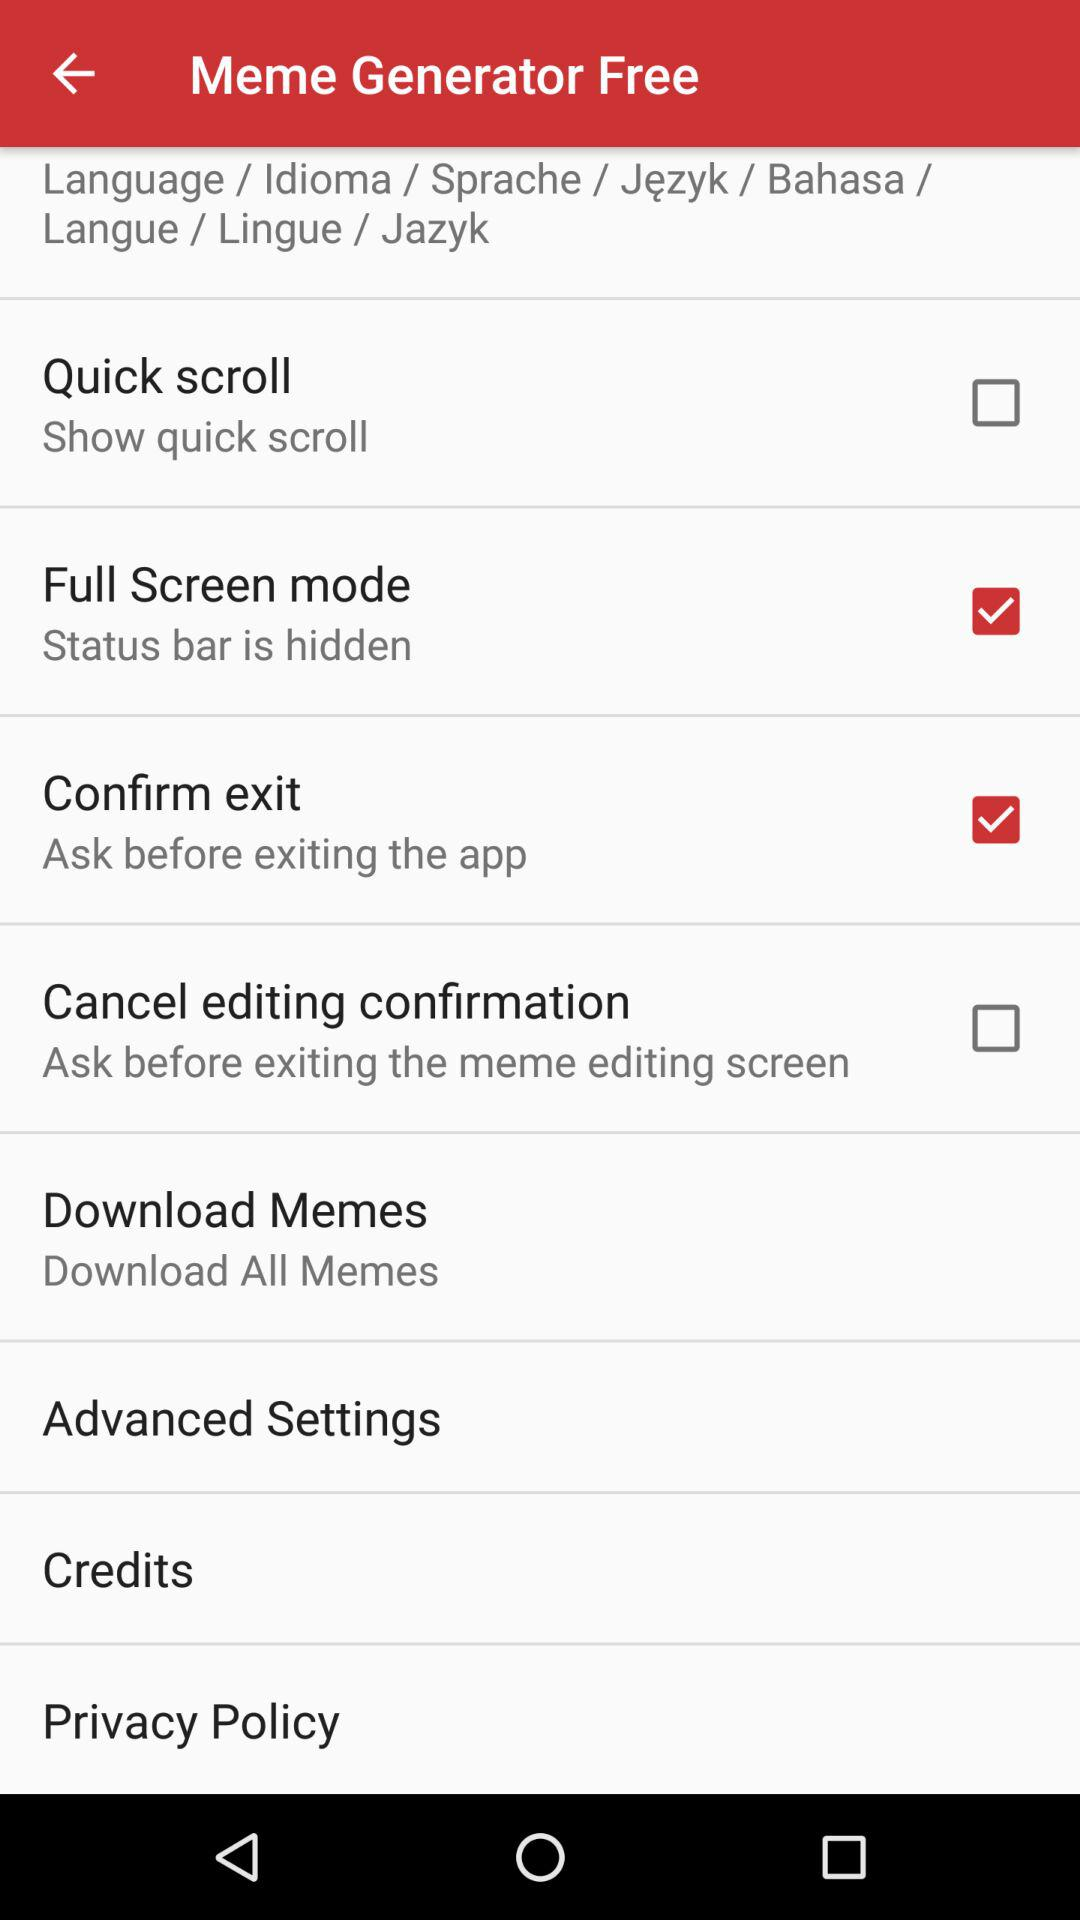What is the status of the "Full Screen mode"? The status is on. 